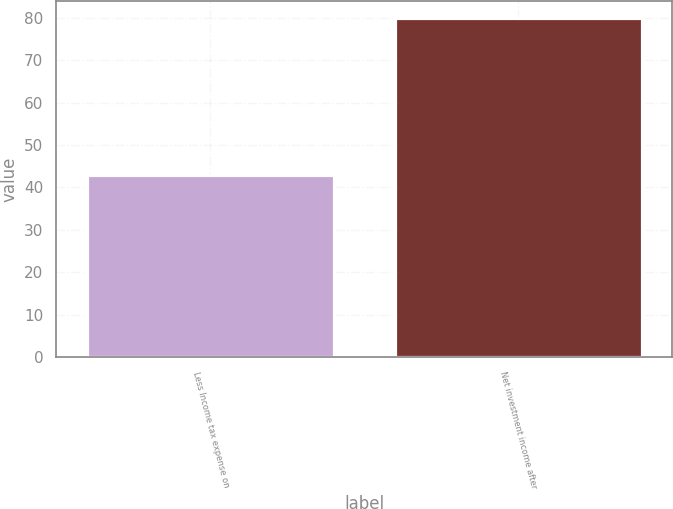Convert chart to OTSL. <chart><loc_0><loc_0><loc_500><loc_500><bar_chart><fcel>Less Income tax expense on<fcel>Net investment income after<nl><fcel>43<fcel>80<nl></chart> 